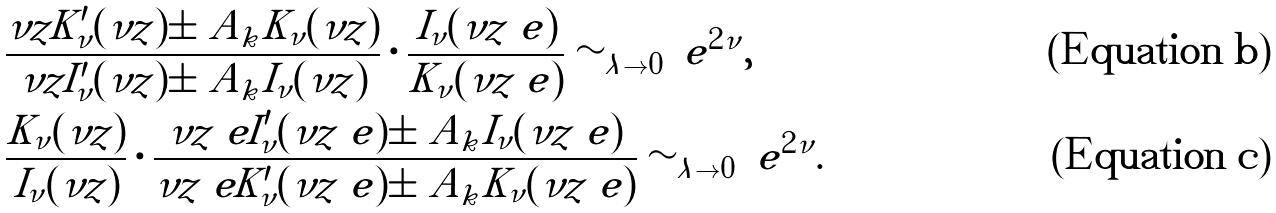Convert formula to latex. <formula><loc_0><loc_0><loc_500><loc_500>& \frac { \nu z K ^ { \prime } _ { \nu } ( \nu z ) \pm \ A _ { k } K _ { \nu } ( \nu z ) } { \nu z I ^ { \prime } _ { \nu } ( \nu z ) \pm \ A _ { k } I _ { \nu } ( \nu z ) } \cdot \frac { I _ { \nu } ( \nu z \ e ) } { K _ { \nu } ( \nu z \ e ) } \sim _ { \lambda \to 0 } \ e ^ { 2 \nu } , \\ & \frac { K _ { \nu } ( \nu z ) } { I _ { \nu } ( \nu z ) } \cdot \frac { \nu z \ e I ^ { \prime } _ { \nu } ( \nu z \ e ) \pm \ A _ { k } I _ { \nu } ( \nu z \ e ) } { \nu z \ e K ^ { \prime } _ { \nu } ( \nu z \ e ) \pm \ A _ { k } K _ { \nu } ( \nu z \ e ) } \sim _ { \lambda \to 0 } \ e ^ { 2 \nu } .</formula> 